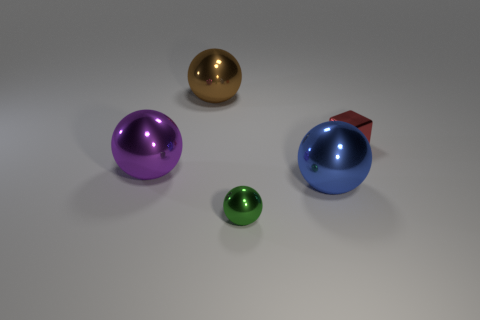Subtract all blue balls. How many balls are left? 3 Add 1 small red metal things. How many objects exist? 6 Subtract all green balls. How many balls are left? 3 Subtract all balls. How many objects are left? 1 Subtract 1 cubes. How many cubes are left? 0 Subtract all blue balls. Subtract all tiny rubber things. How many objects are left? 4 Add 4 blue objects. How many blue objects are left? 5 Add 5 big brown cubes. How many big brown cubes exist? 5 Subtract 1 green spheres. How many objects are left? 4 Subtract all green cubes. Subtract all brown balls. How many cubes are left? 1 